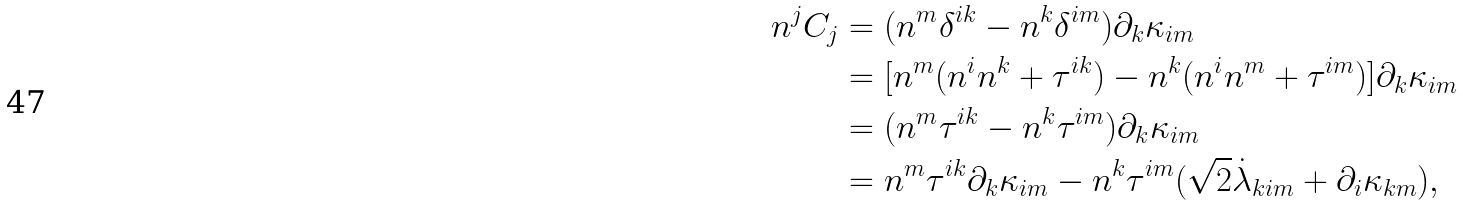<formula> <loc_0><loc_0><loc_500><loc_500>n ^ { j } C _ { j } & = ( n ^ { m } \delta ^ { i k } - n ^ { k } \delta ^ { i m } ) \partial _ { k } \kappa _ { i m } \\ & = [ n ^ { m } ( n ^ { i } n ^ { k } + \tau ^ { i k } ) - n ^ { k } ( n ^ { i } n ^ { m } + \tau ^ { i m } ) ] \partial _ { k } \kappa _ { i m } \\ & = ( n ^ { m } \tau ^ { i k } - n ^ { k } \tau ^ { i m } ) \partial _ { k } \kappa _ { i m } \\ & = n ^ { m } \tau ^ { i k } \partial _ { k } \kappa _ { i m } - n ^ { k } \tau ^ { i m } ( \sqrt { 2 } \dot { \lambda } _ { k i m } + \partial _ { i } \kappa _ { k m } ) ,</formula> 